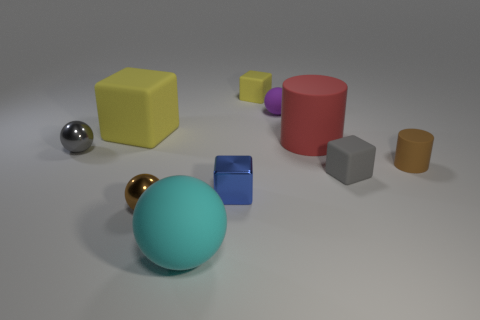What number of things are rubber objects that are to the left of the tiny brown sphere or rubber blocks on the right side of the cyan rubber ball?
Your answer should be very brief. 3. Does the metallic cube have the same color as the big ball?
Your answer should be very brief. No. There is a small sphere that is the same color as the small matte cylinder; what is its material?
Make the answer very short. Metal. Are there fewer cyan things in front of the tiny brown rubber cylinder than large rubber balls that are behind the small gray matte block?
Keep it short and to the point. No. Is the small gray sphere made of the same material as the blue cube?
Your answer should be very brief. Yes. What size is the ball that is both to the right of the small brown sphere and in front of the tiny blue metallic thing?
Offer a terse response. Large. What shape is the gray rubber thing that is the same size as the metal cube?
Your response must be concise. Cube. What is the material of the tiny brown object behind the rubber cube in front of the tiny thing on the left side of the large block?
Keep it short and to the point. Rubber. Is the shape of the yellow rubber object that is in front of the purple rubber sphere the same as the brown object that is to the right of the purple thing?
Offer a very short reply. No. What number of other objects are the same material as the big yellow cube?
Offer a very short reply. 6. 